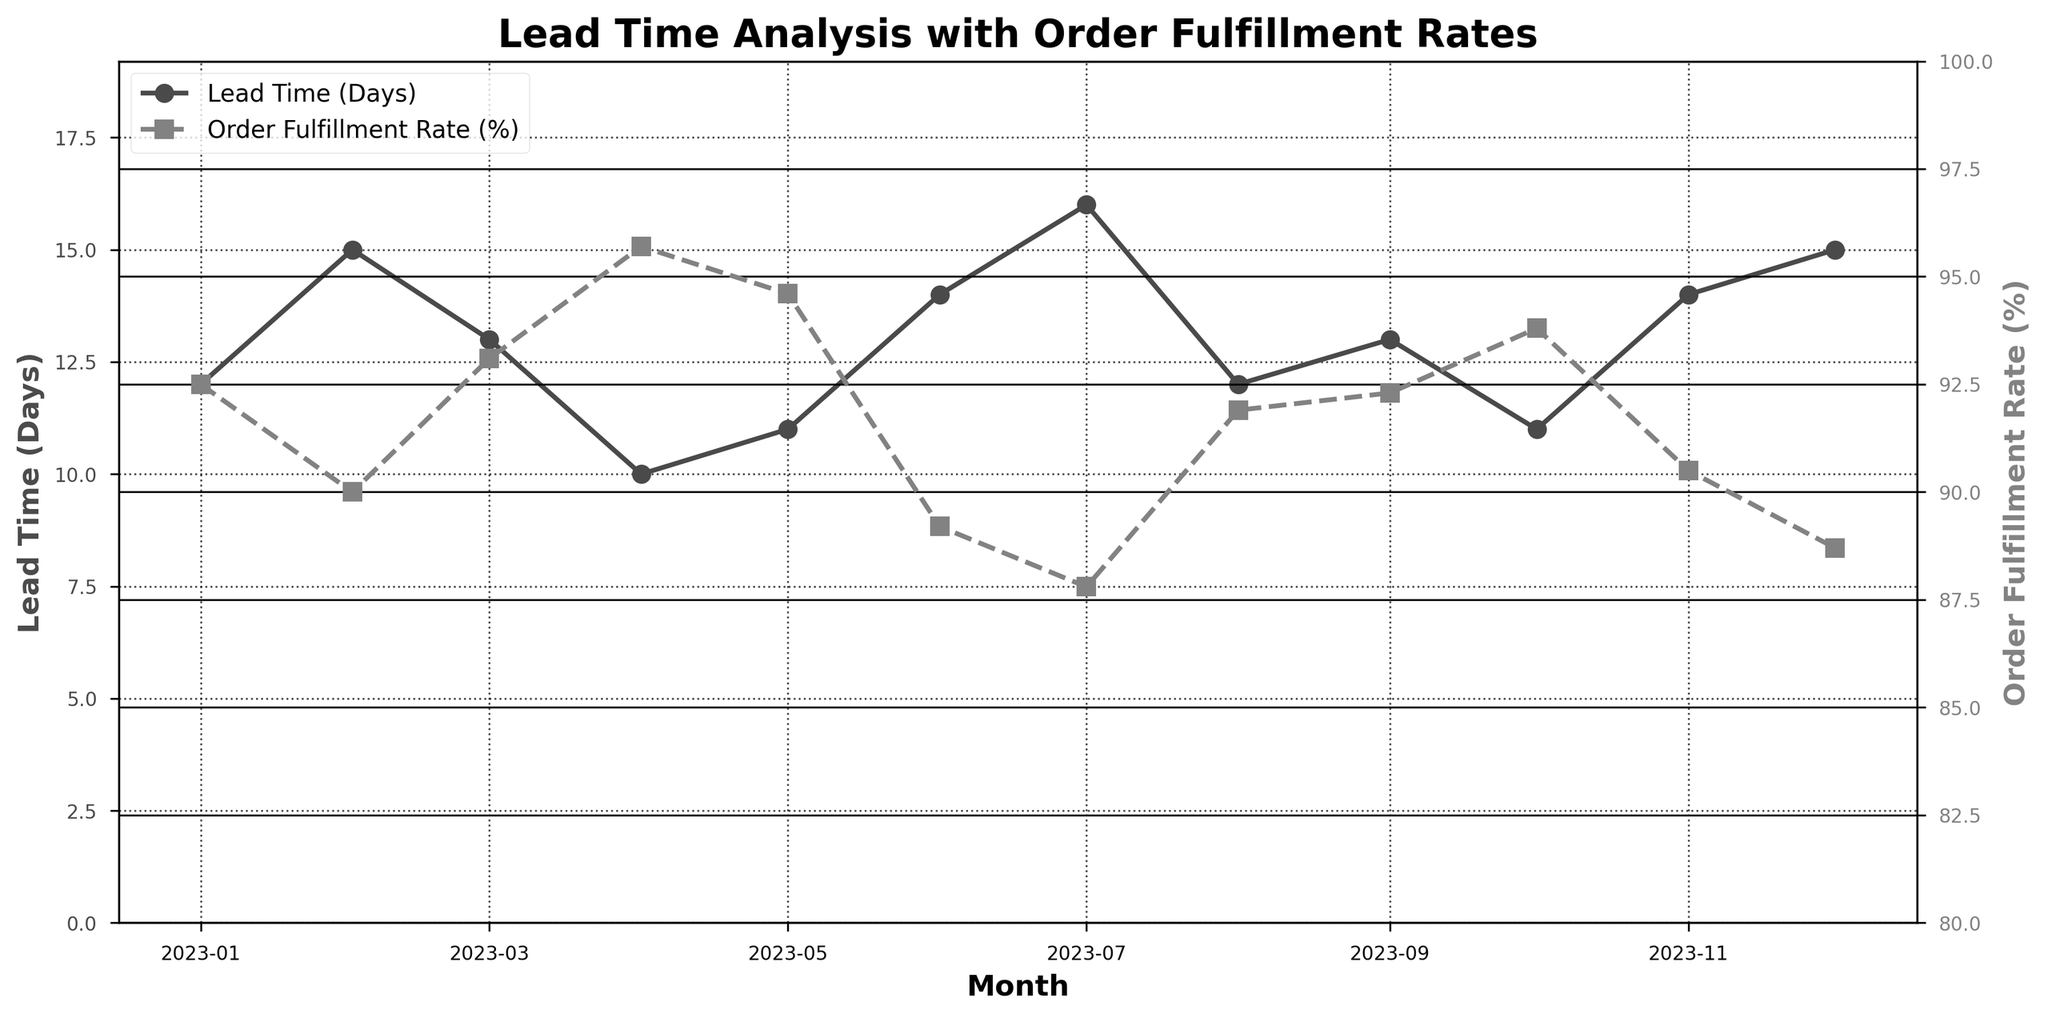What's the title of the plot? The title of the plot is found at the top of the figure. It reads "Lead Time Analysis with Order Fulfillment Rates".
Answer: Lead Time Analysis with Order Fulfillment Rates How many months of data are displayed in the plot? The data points are represented by markers on the plot's x-axis. Counting each marker or data point reveals that there are 12 months displayed.
Answer: 12 What are the values for Lead Time in January 2023? By locating January 2023 on the x-axis and observing the corresponding value on the y-axis for Lead Time, we find that the lead time is plotted at 12 days.
Answer: 12 days What is the range of Order Fulfillment Rates (%) shown in the plot? The y-axis for Order Fulfillment Rate (%), at the right side, shows values ranging from 80% to 100%.
Answer: 80% to 100% Which month has the highest Order Fulfillment Rate (%)? Checking each peak on the Order Fulfillment Rate line (squares), the highest point reaches 95.7% in April 2023.
Answer: April 2023 During which month did the Lead Time reach its maximum? Looking for the highest peak on the Lead Time line (circles), the maximum Lead Time of 16 days is observed in July 2023.
Answer: July 2023 What is the average Order Fulfillment Rate (%) for the months of January 2023 to March 2023? Adding the Order Fulfillment Rates for January, February, and March 2023 (92.5 + 90.0 + 93.1)/3 provides the average. (92.5 + 90.0 + 93.1) / 3 = 275.6 / 3 ≈ 91.87%.
Answer: ≈ 91.87% Did the Order Fulfillment Rate (%) in June 2023 have a higher or lower value compared to May 2023? Comparing the y-values for June and May 2023 on the Order Fulfillment Rate line, June's rate of 89.2% is lower than May's 94.6%.
Answer: Lower What is the difference in Lead Time between February 2023 and April 2023? The Lead Time for February is 15 days, and for April, it is 10 days. Subtracting these values gives the difference: 15 - 10 = 5 days.
Answer: 5 days Which month shows both lower Lead Time and higher Order Fulfillment Rate than the previous month? Comparing each month sequentially, April 2023 shows a Lead Time of 10 days (lower than 13 days in March) and an Order Fulfillment Rate of 95.7% (higher than 93.1% in March).
Answer: April 2023 